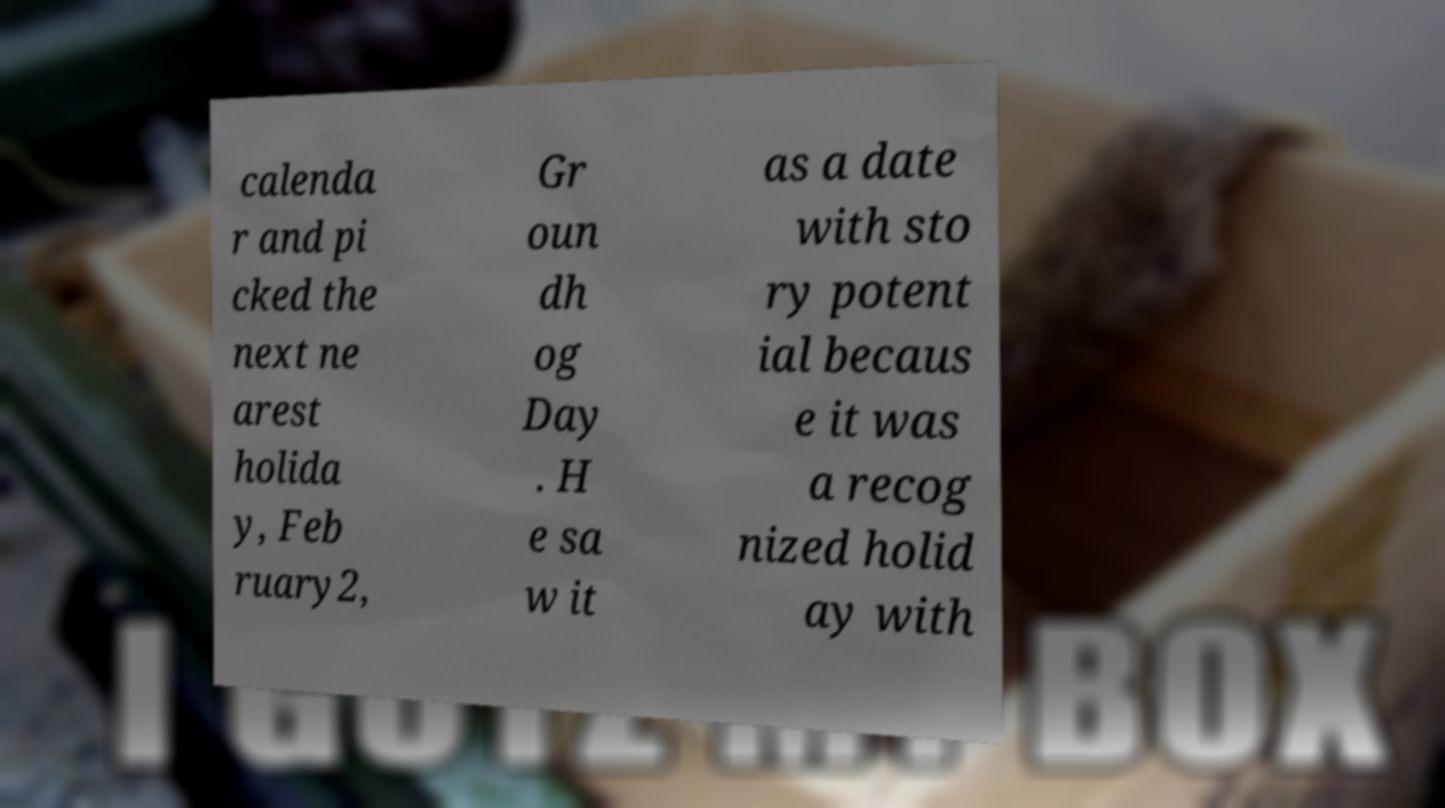Can you accurately transcribe the text from the provided image for me? calenda r and pi cked the next ne arest holida y, Feb ruary2, Gr oun dh og Day . H e sa w it as a date with sto ry potent ial becaus e it was a recog nized holid ay with 